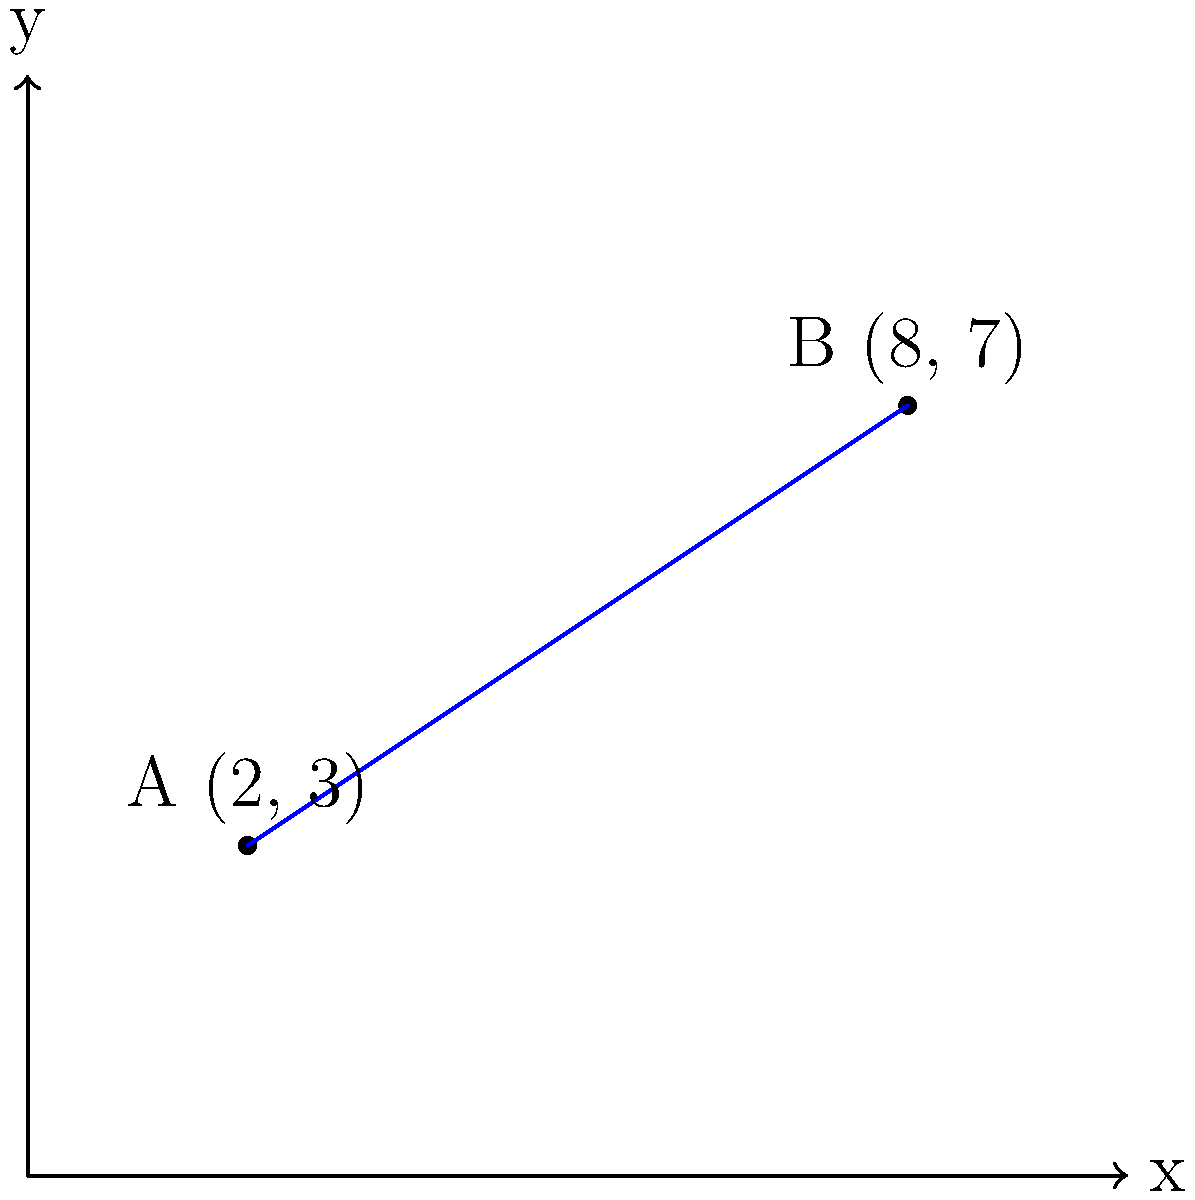As an emergency management official, you need to calculate the distance between two emergency response centers. Center A is located at coordinates (2, 3) and Center B is at (8, 7) on your grid map. Using the distance formula, determine the straight-line distance between these two centers. Round your answer to the nearest tenth of a mile. To solve this problem, we'll use the distance formula derived from the Pythagorean theorem:

$$d = \sqrt{(x_2 - x_1)^2 + (y_2 - y_1)^2}$$

Where $(x_1, y_1)$ are the coordinates of point A and $(x_2, y_2)$ are the coordinates of point B.

Step 1: Identify the coordinates
A: $(x_1, y_1) = (2, 3)$
B: $(x_2, y_2) = (8, 7)$

Step 2: Plug the values into the distance formula
$$d = \sqrt{(8 - 2)^2 + (7 - 3)^2}$$

Step 3: Simplify the expressions inside the parentheses
$$d = \sqrt{6^2 + 4^2}$$

Step 4: Calculate the squares
$$d = \sqrt{36 + 16}$$

Step 5: Add the values under the square root
$$d = \sqrt{52}$$

Step 6: Calculate the square root and round to the nearest tenth
$$d \approx 7.2$$

Therefore, the distance between the two emergency response centers is approximately 7.2 miles.
Answer: 7.2 miles 